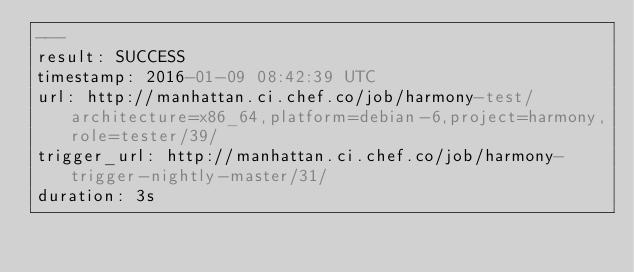Convert code to text. <code><loc_0><loc_0><loc_500><loc_500><_YAML_>---
result: SUCCESS
timestamp: 2016-01-09 08:42:39 UTC
url: http://manhattan.ci.chef.co/job/harmony-test/architecture=x86_64,platform=debian-6,project=harmony,role=tester/39/
trigger_url: http://manhattan.ci.chef.co/job/harmony-trigger-nightly-master/31/
duration: 3s
</code> 